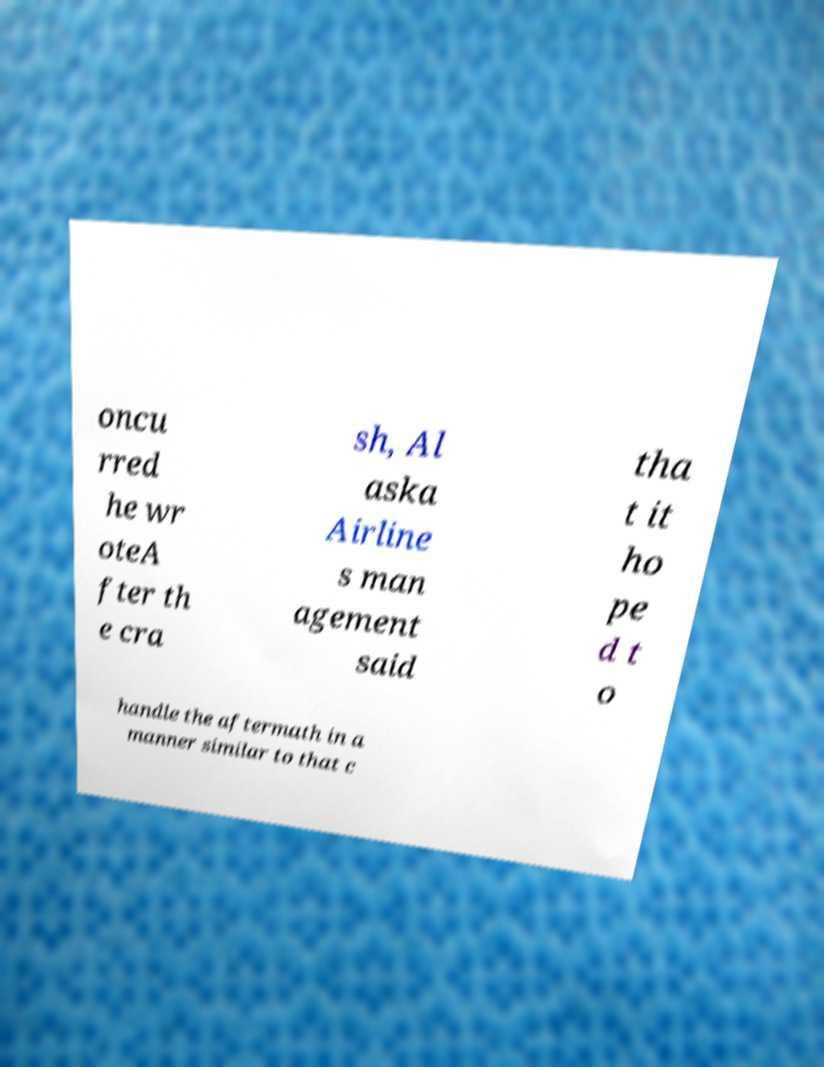Please read and relay the text visible in this image. What does it say? oncu rred he wr oteA fter th e cra sh, Al aska Airline s man agement said tha t it ho pe d t o handle the aftermath in a manner similar to that c 